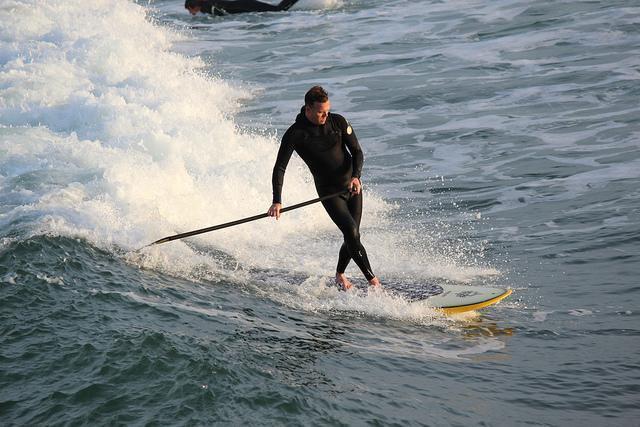How many laptops are in the photo?
Give a very brief answer. 0. 